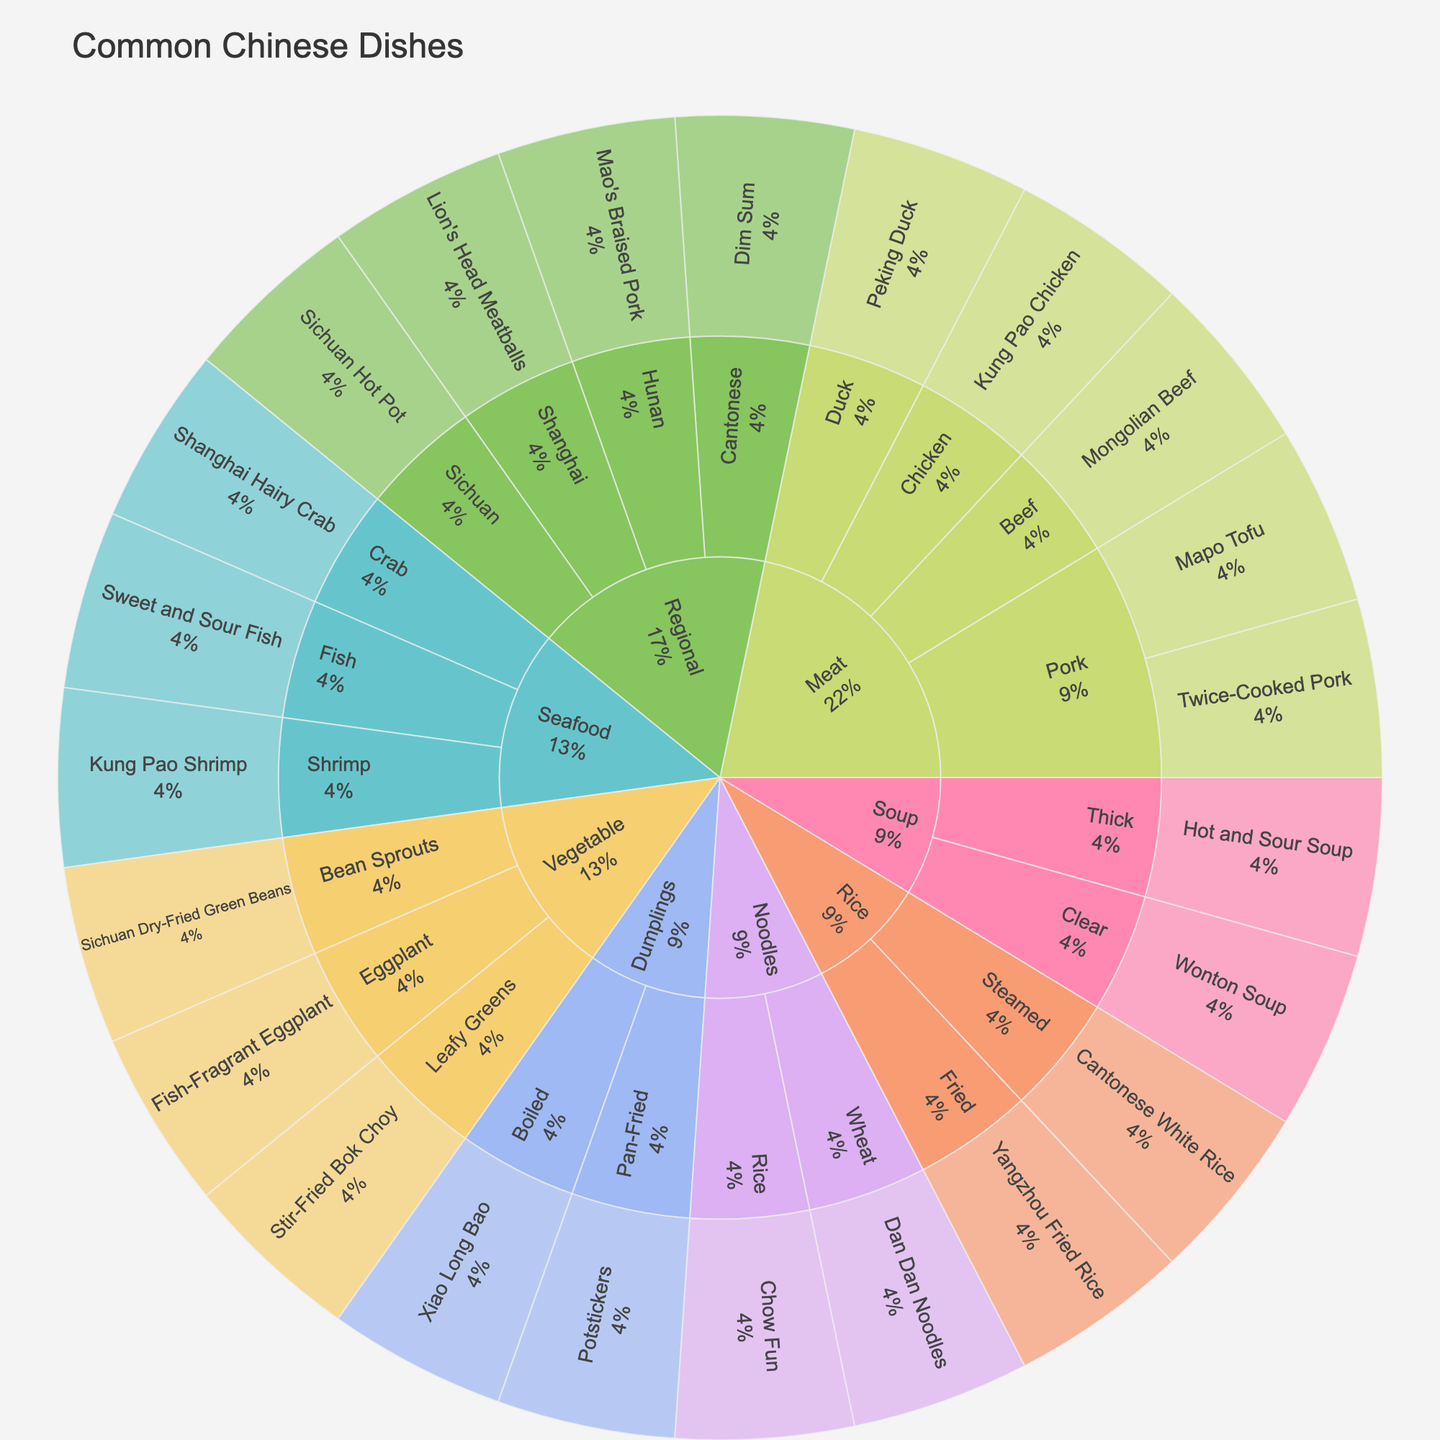What's the title of the sunburst plot? The title is displayed at the top of the figure and summarizes the content of the plot.
Answer: Common Chinese Dishes What is the category of 'Fish-Fragrant Eggplant'? The category is shown at the first level of the plot and it groups the dish by a broader classification. Locate 'Fish-Fragrant Eggplant' and trace back to its category.
Answer: Vegetable Which subcategory under 'Noodles' has more dishes? Check the subcategories under 'Noodles' and count the number of dishes in each subcategory to see which has more.
Answer: Wheat How many dishes are categorized under 'Soup'? Count the total number of segments branching out from 'Soup'.
Answer: 2 Which dish falls under both 'Seafood' and 'Shrimp'? Navigate to 'Seafood', then to 'Shrimp' and identify the dish listed.
Answer: Kung Pao Shrimp How many dishes are in the 'Vegetable' category? Sum the number of dishes expanding from the 'Vegetable' category.
Answer: 3 Is the number of 'Meat' dishes greater than the number of 'Rice' and 'Seafood' dishes combined? Count the number of dishes under 'Meat' and then sum up the total dishes under 'Rice' and 'Seafood' to compare these numbers.
Answer: Yes Which regions have dishes included in the plot? Identify all regions listed within the 'Regional' category.
Answer: Sichuan, Cantonese, Hunan, Shanghai What percentage of dishes are in the 'Dumplings' category? Each segment of the plot shows a percentage. Find the 'Dumplings' slice and read its percentage.
Answer: 10% Compare the number of dishes listed under 'Meat' subcategories 'Pork' and 'Beef'. Which one has more? Look at the subcategories under 'Meat', identify 'Pork' and 'Beef', and count the number of dishes under each to compare.
Answer: Pork 